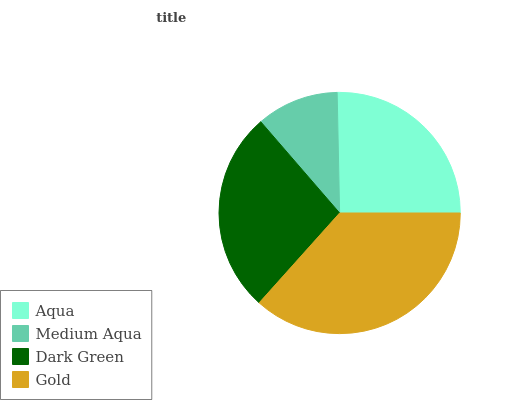Is Medium Aqua the minimum?
Answer yes or no. Yes. Is Gold the maximum?
Answer yes or no. Yes. Is Dark Green the minimum?
Answer yes or no. No. Is Dark Green the maximum?
Answer yes or no. No. Is Dark Green greater than Medium Aqua?
Answer yes or no. Yes. Is Medium Aqua less than Dark Green?
Answer yes or no. Yes. Is Medium Aqua greater than Dark Green?
Answer yes or no. No. Is Dark Green less than Medium Aqua?
Answer yes or no. No. Is Dark Green the high median?
Answer yes or no. Yes. Is Aqua the low median?
Answer yes or no. Yes. Is Aqua the high median?
Answer yes or no. No. Is Medium Aqua the low median?
Answer yes or no. No. 